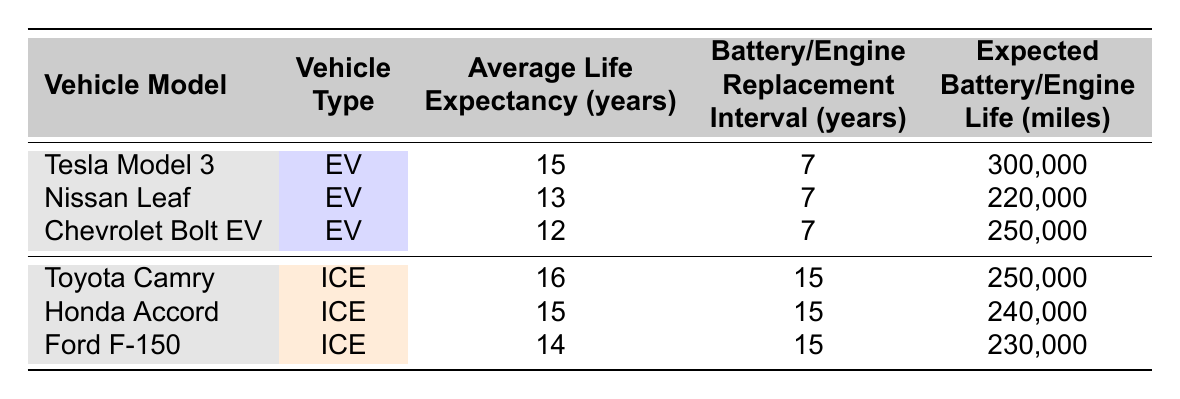What is the average life expectancy of electric vehicles listed in the table? To find the average life expectancy of electric vehicles, we look at the values for Tesla Model 3 (15 years), Nissan Leaf (13 years), and Chevrolet Bolt EV (12 years). First, sum these values: 15 + 13 + 12 = 40. Then, divide by the number of vehicles (3): 40 / 3 = 13.33. Therefore, the average life expectancy of the electric vehicles is approximately 13.33 years.
Answer: 13.33 Which vehicle has the longest average life expectancy? Looking at the "Average Life Expectancy" column, we can see that the Toyota Camry has the highest value at 16 years, more than all other vehicles listed.
Answer: Toyota Camry Is the expected battery life of the Tesla Model 3 longer than the expected engine life of the Ford F-150? The expected battery life of the Tesla Model 3 is 300,000 miles, and the expected engine life of the Ford F-150 is 230,000 miles. Since 300,000 is greater than 230,000, the statement is true.
Answer: Yes What is the difference in average life expectancy between the best electric vehicle and the best internal combustion engine vehicle? The best electric vehicle, the Tesla Model 3, has an average life expectancy of 15 years, and the best internal combustion engine vehicle, the Toyota Camry, has 16 years. The difference is 16 - 15 = 1 year.
Answer: 1 year Is the average battery replacement interval for electric vehicles the same as the engine rebuild interval for internal combustion engine vehicles? According to the table, the battery replacement interval for all electric vehicles is 7 years, while the engine rebuild interval for internal combustion engine vehicles is 15 years. Since 7 years is not equal to 15 years, the statement is false.
Answer: No What is the expected total mileage of the Nissan Leaf and Chevrolet Bolt EV combined? The expected mileage for the Nissan Leaf is 220,000 miles and for the Chevrolet Bolt EV is 250,000 miles. Adding these gives 220,000 + 250,000 = 470,000 miles.
Answer: 470,000 miles Which vehicle has a shorter average life expectancy, the Chevrolet Bolt EV or the Honda Accord? The Chevrolet Bolt EV has an average life expectancy of 12 years, while the Honda Accord has an average life expectancy of 15 years. Since 12 years is less than 15 years, the Chevrolet Bolt EV has a shorter life expectancy.
Answer: Chevrolet Bolt EV How many vehicles listed in the table have an average life expectancy of 15 years or more? The vehicles with an average life expectancy of 15 years or more are the Tesla Model 3 (15 years), Toyota Camry (16 years), and Honda Accord (15 years). This gives us a total of 3 vehicles.
Answer: 3 vehicles 